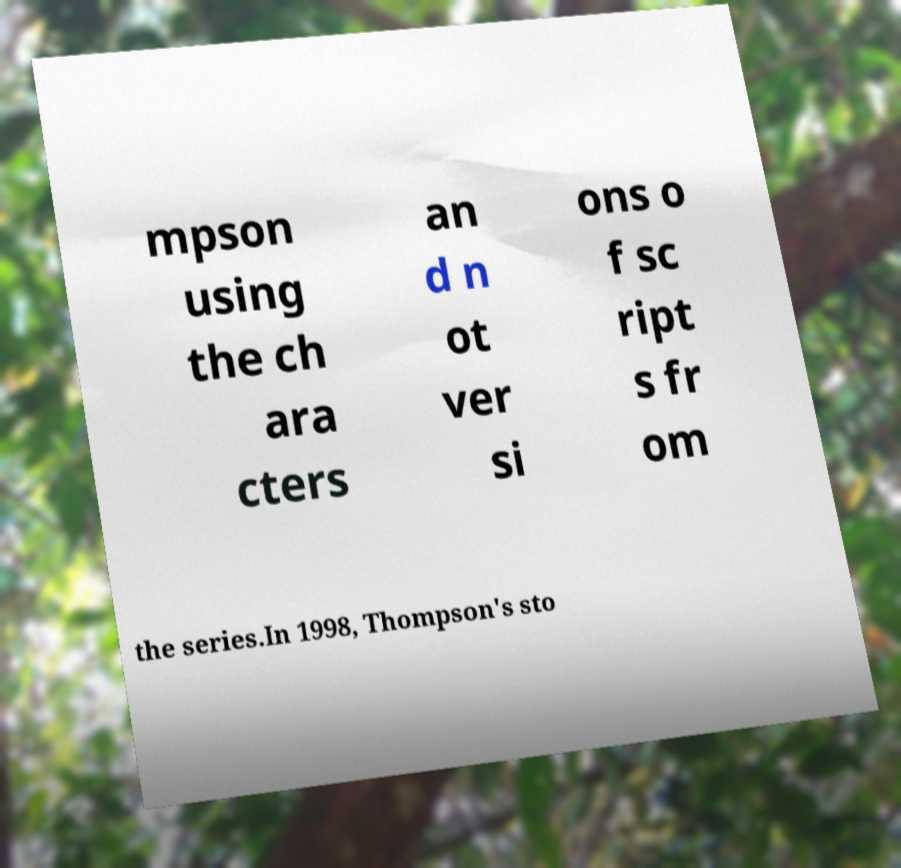Could you assist in decoding the text presented in this image and type it out clearly? mpson using the ch ara cters an d n ot ver si ons o f sc ript s fr om the series.In 1998, Thompson's sto 